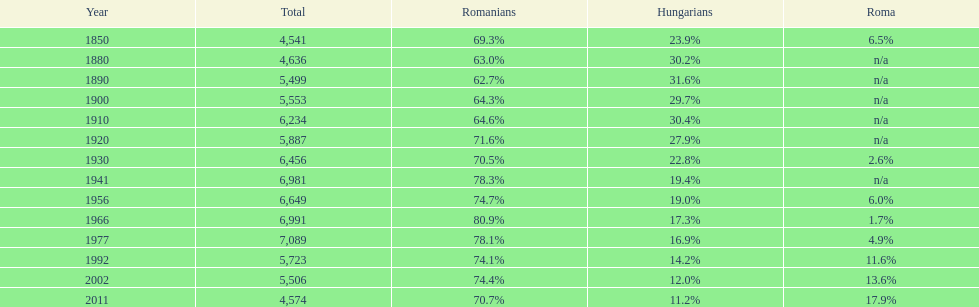What year saw a hungarian population of 6,981, comprising 1 1941. Parse the full table. {'header': ['Year', 'Total', 'Romanians', 'Hungarians', 'Roma'], 'rows': [['1850', '4,541', '69.3%', '23.9%', '6.5%'], ['1880', '4,636', '63.0%', '30.2%', 'n/a'], ['1890', '5,499', '62.7%', '31.6%', 'n/a'], ['1900', '5,553', '64.3%', '29.7%', 'n/a'], ['1910', '6,234', '64.6%', '30.4%', 'n/a'], ['1920', '5,887', '71.6%', '27.9%', 'n/a'], ['1930', '6,456', '70.5%', '22.8%', '2.6%'], ['1941', '6,981', '78.3%', '19.4%', 'n/a'], ['1956', '6,649', '74.7%', '19.0%', '6.0%'], ['1966', '6,991', '80.9%', '17.3%', '1.7%'], ['1977', '7,089', '78.1%', '16.9%', '4.9%'], ['1992', '5,723', '74.1%', '14.2%', '11.6%'], ['2002', '5,506', '74.4%', '12.0%', '13.6%'], ['2011', '4,574', '70.7%', '11.2%', '17.9%']]} 